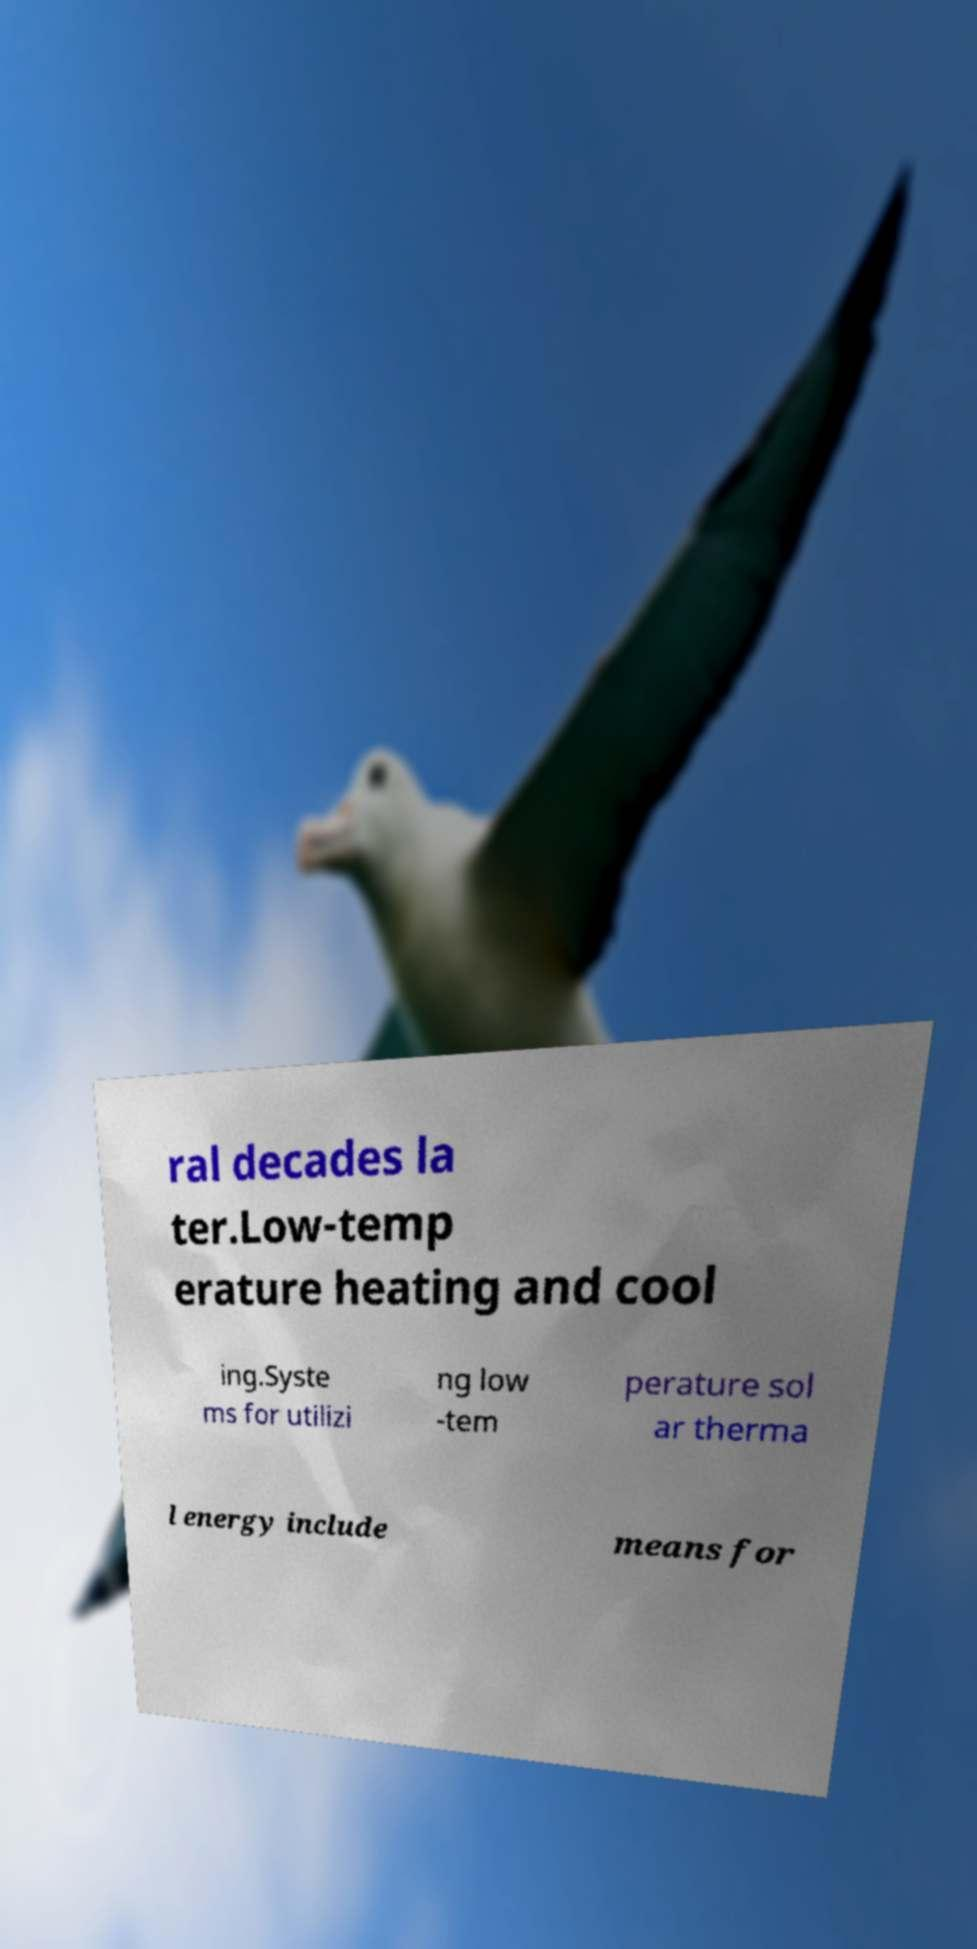What messages or text are displayed in this image? I need them in a readable, typed format. ral decades la ter.Low-temp erature heating and cool ing.Syste ms for utilizi ng low -tem perature sol ar therma l energy include means for 